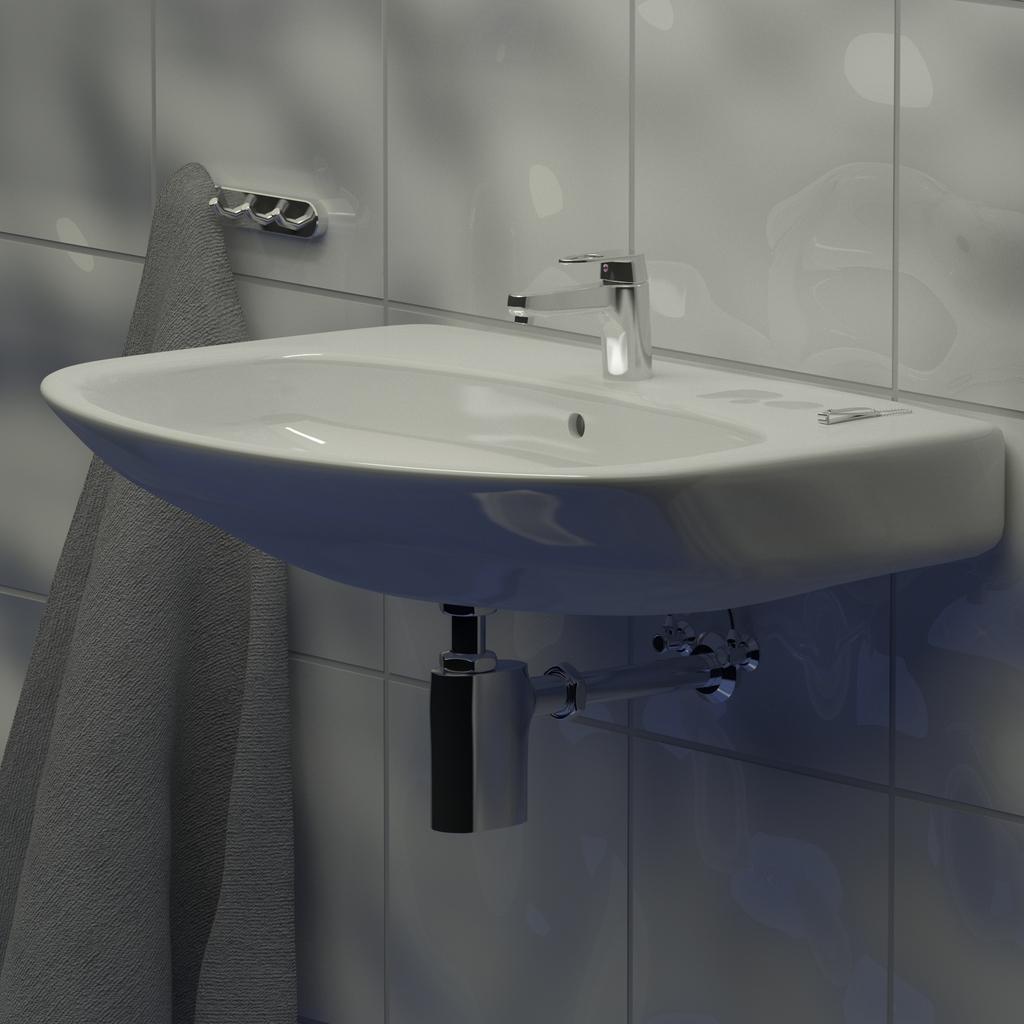In one or two sentences, can you explain what this image depicts? In the picture we can see a sink which is white in color to the wall with a tap and under it we can see a pipe and beside it we can see a towel to the hanger. 